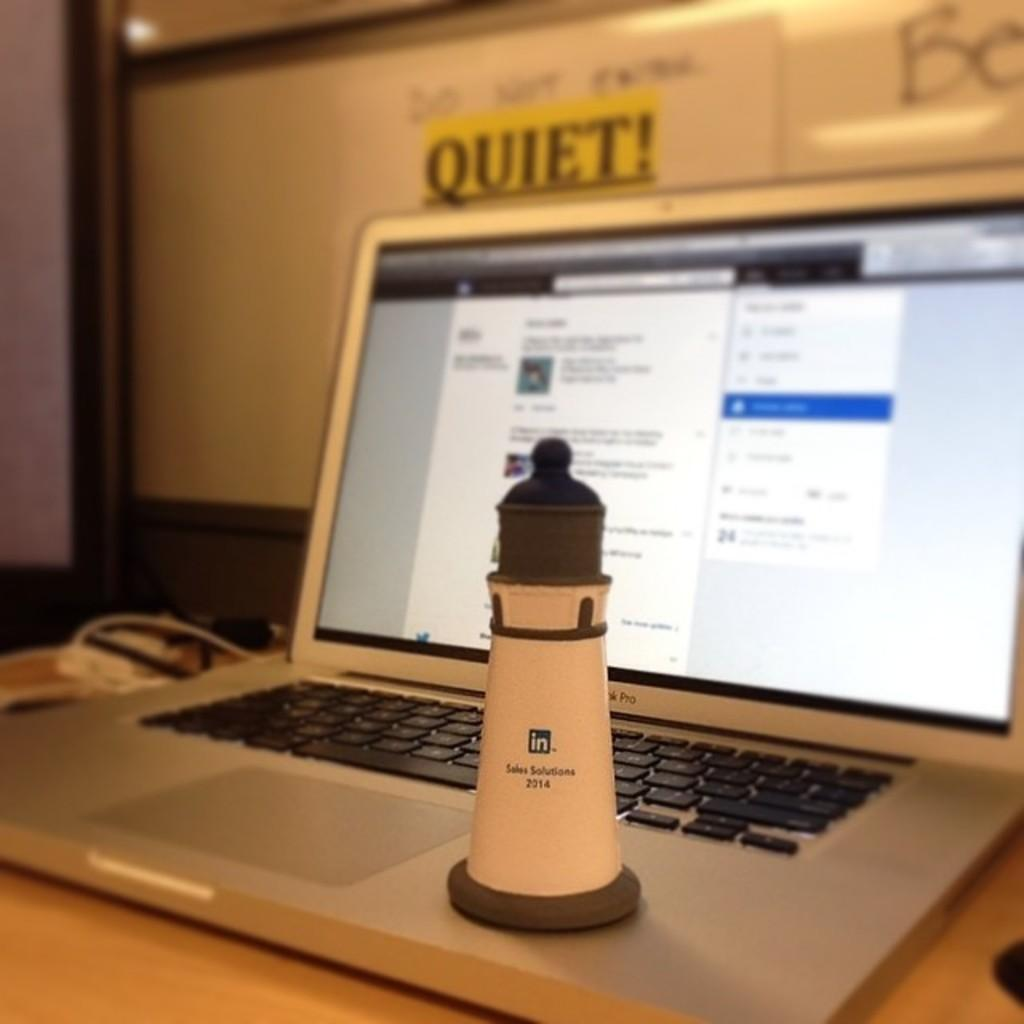<image>
Write a terse but informative summary of the picture. a blurry macbook screen on top of the keyboard is a linked in figurine that says sales solutions 2014 